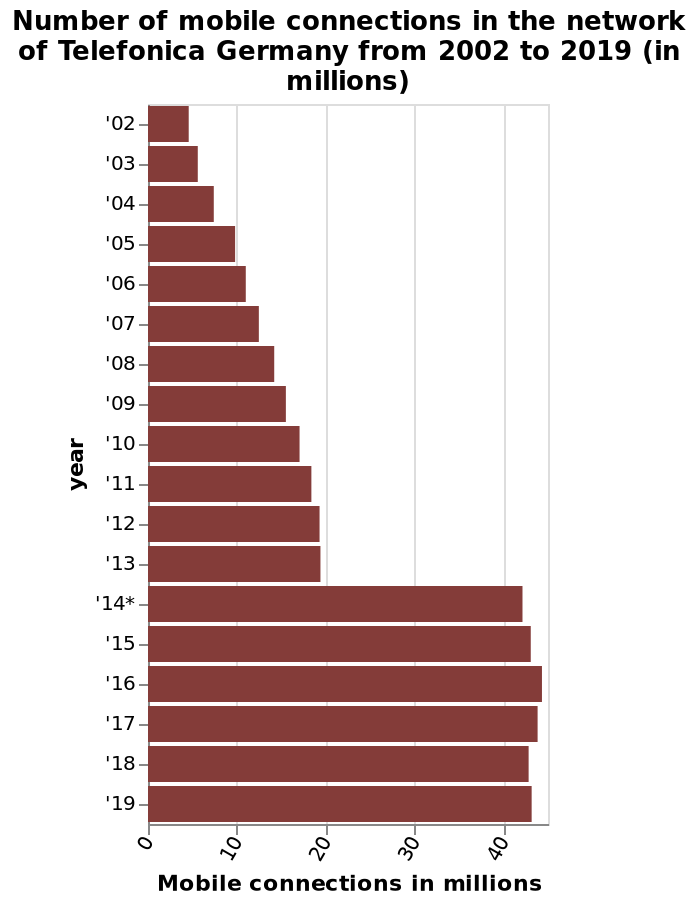<image>
How many different years are included in the bar chart?  The bar chart includes a total of 18 different years, from 2002 to 2019. What does the bar chart show? The bar chart shows the number of mobile connections in the network of Telefonica Germany from 2002 to 2019, represented in millions. Did the number of mobile connections increase or decrease from 2014-2019?  The number of mobile connections remained stable from 2014-2019. How did the number of mobile connections grow from 2002-2014?  From 2002-2014, the number of mobile connections grew steadily. please summary the statistics and relations of the chart The number of mobile connections grew rapidly from 2014From 2014-2019, the number of mobile connections has remained stableFrom 2002-2014, the number of mobile connections grew steadily The highest year for connections was 2016. Does the line graph show the number of mobile connections in the network of Telefonica Germany from 2002 to 2019, represented in thousands? No.The bar chart shows the number of mobile connections in the network of Telefonica Germany from 2002 to 2019, represented in millions. 